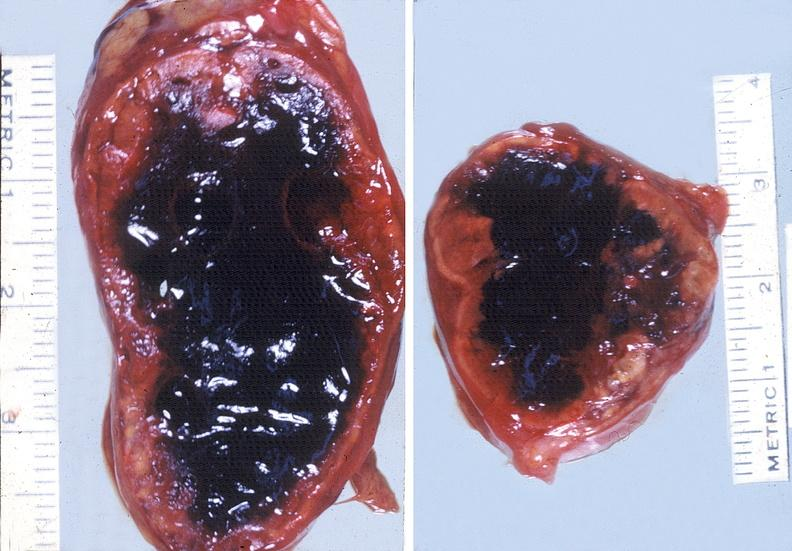what does this image show?
Answer the question using a single word or phrase. Adrenal 